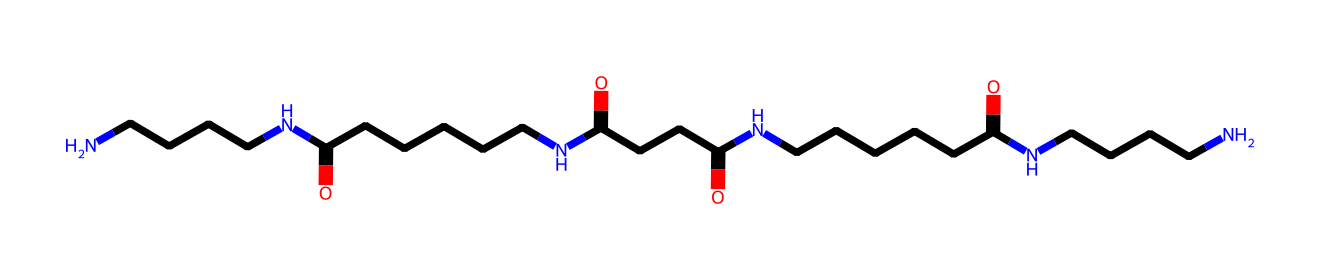What type of polymer is represented in the chemical structure? The structure depicts an amide polymer, as indicated by the presence of multiple -CONH- linkages. This suggests the material is a type of polyamide, commonly known as nylon.
Answer: polyamide How many nitrogen atoms are present in the structure? Counting the nitrogen atoms in the structure shows that there are six -NH- groups (represented by the letters 'N'). Each occurrence indicates the presence of nitrogen.
Answer: six What is the total number of carbon atoms in the chemical structure? By carefully counting the carbon atoms in the given SMILES representation, we find that there are 18 carbon atoms in total. Each 'C' within the structure corresponds to one carbon atom.
Answer: eighteen What kind of fibers are produced from this polymer? The polymer chain structure suggests that it can create strong, synthetic fibers that are typical of nylon, which is widely used in clothing, including professional attire.
Answer: nylon fibers How does the polymer structure contribute to the material properties of professional attire? The presence of amide linkages in the polymer allows the fibers to exhibit strength, durability, and resistance to wear, which are desirable traits for professional clothing.
Answer: strength and durability What type of functional groups dominate in this chemical structure? The dominant functional groups in the structure are amide groups (-CONH-), which give nylon its specific properties related to melting point and tensile strength.
Answer: amide groups 